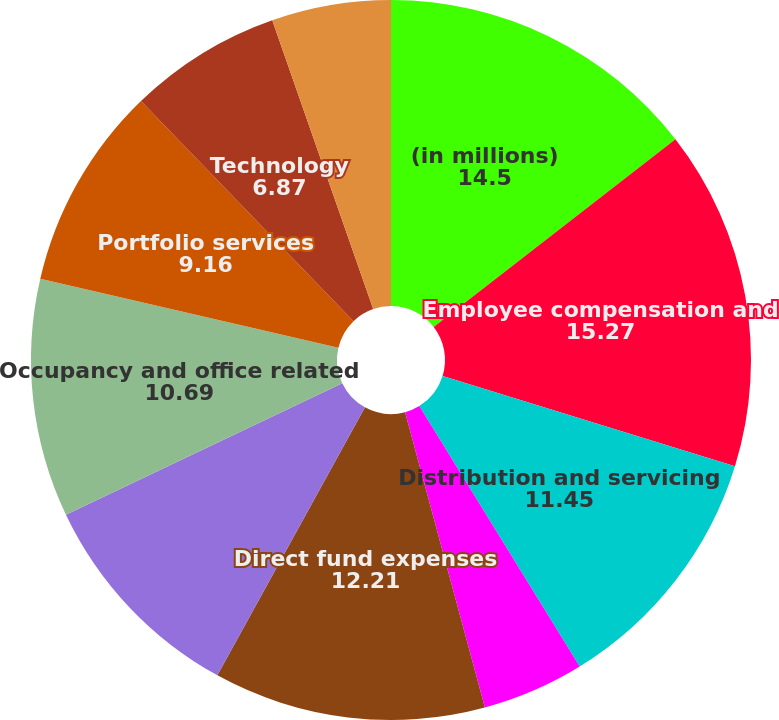Convert chart. <chart><loc_0><loc_0><loc_500><loc_500><pie_chart><fcel>(in millions)<fcel>Employee compensation and<fcel>Distribution and servicing<fcel>Amortization of deferred sales<fcel>Direct fund expenses<fcel>Marketing and promotional<fcel>Occupancy and office related<fcel>Portfolio services<fcel>Technology<fcel>Professional services<nl><fcel>14.5%<fcel>15.27%<fcel>11.45%<fcel>4.58%<fcel>12.21%<fcel>9.92%<fcel>10.69%<fcel>9.16%<fcel>6.87%<fcel>5.35%<nl></chart> 